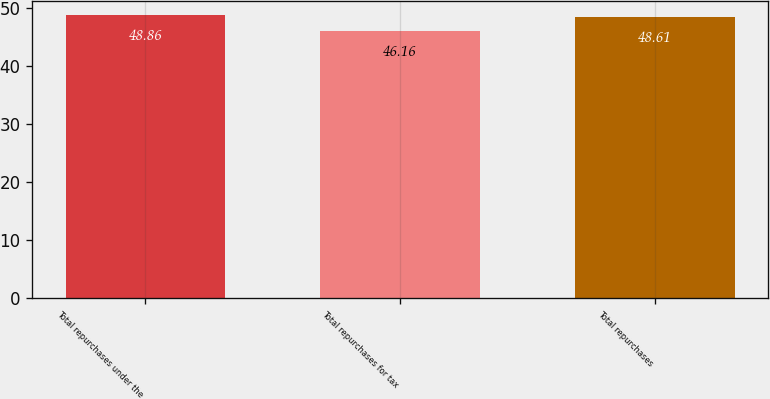Convert chart. <chart><loc_0><loc_0><loc_500><loc_500><bar_chart><fcel>Total repurchases under the<fcel>Total repurchases for tax<fcel>Total repurchases<nl><fcel>48.86<fcel>46.16<fcel>48.61<nl></chart> 